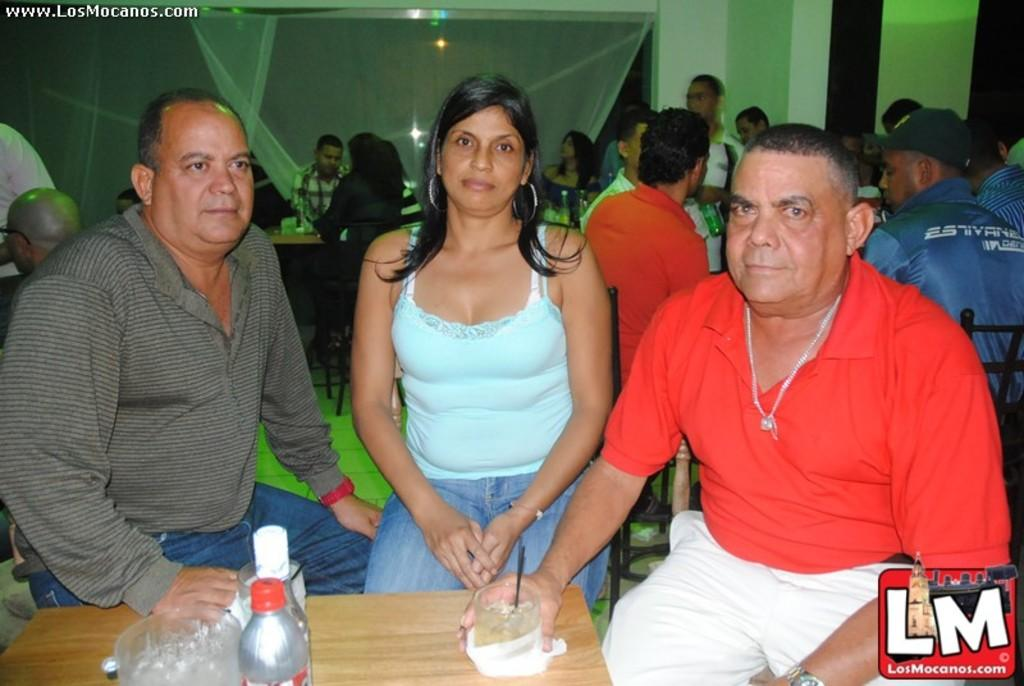How many people are present in the image? There are three people in the image. What are the people doing in the image? The people are sitting on chairs. What is the primary piece of furniture in the image? There is a table in the image. Can you describe any objects on the table? The facts mention that there are unspecified objects on the table, but we cannot provide more details without additional information. How many babies are crawling under the table in the image? There is no mention of babies or crawling in the image, so we cannot answer this question. 